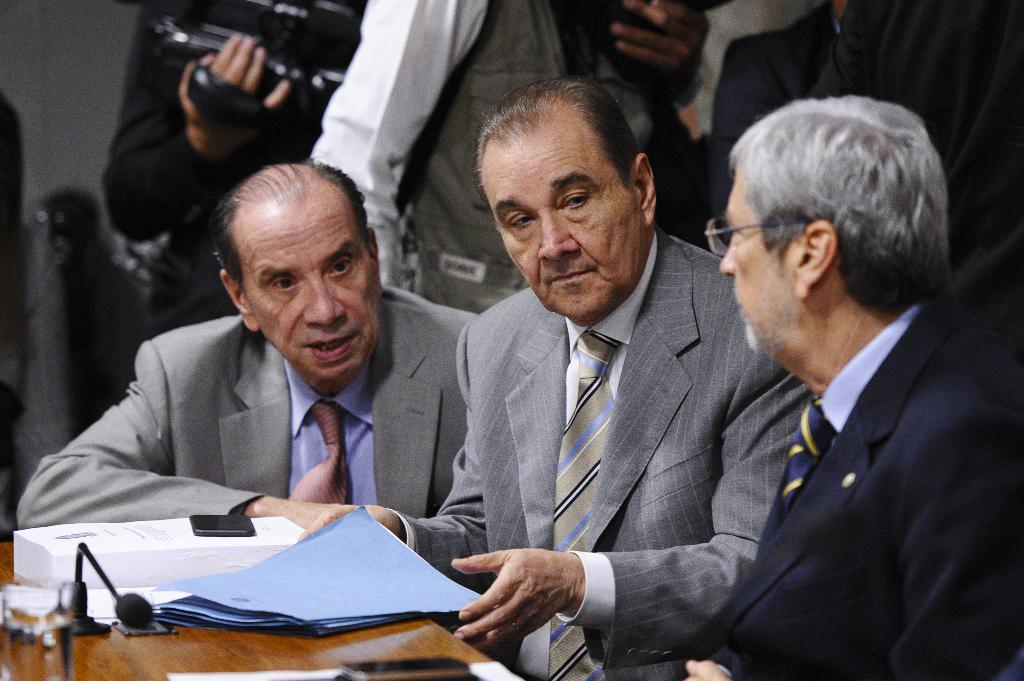How many people are sitting in the image? There are three people sitting in the image. What are the sitting individuals wearing? The people sitting in the image are wearing suits. What can be seen on the table in the image? There are books and a microphone on the table in the image. What is the position of the standing individuals in relation to the sitting individuals? There are people standing behind the sitting individuals in the image. What type of detail is present on the key in the image? There is no key present in the image. How is the waste being managed in the image? There is no mention of waste management in the image. 